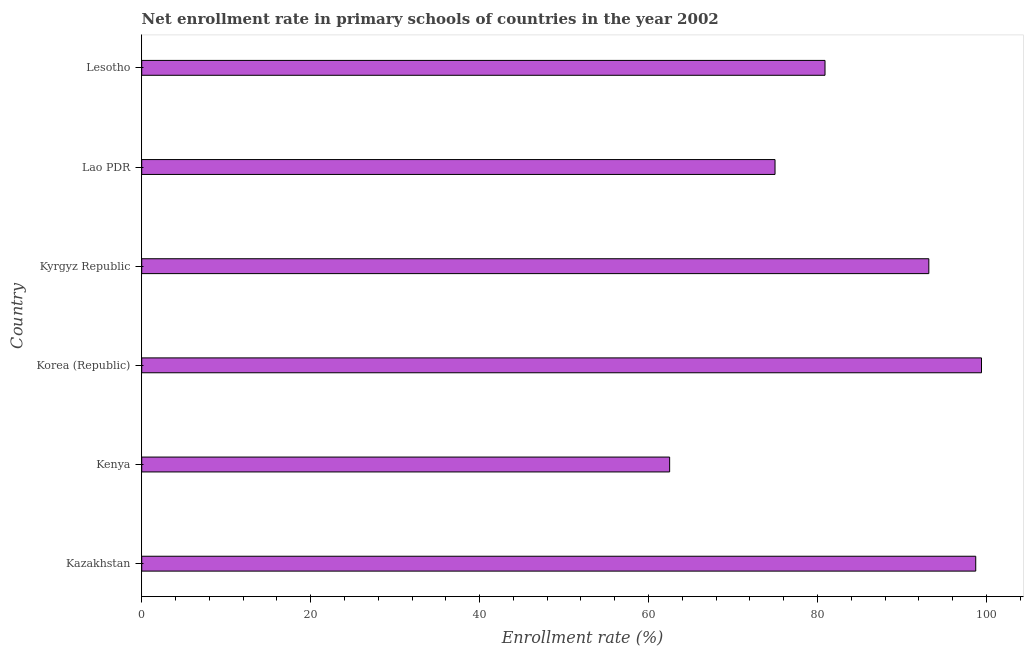Does the graph contain grids?
Your response must be concise. No. What is the title of the graph?
Make the answer very short. Net enrollment rate in primary schools of countries in the year 2002. What is the label or title of the X-axis?
Provide a succinct answer. Enrollment rate (%). What is the net enrollment rate in primary schools in Korea (Republic)?
Provide a succinct answer. 99.42. Across all countries, what is the maximum net enrollment rate in primary schools?
Offer a very short reply. 99.42. Across all countries, what is the minimum net enrollment rate in primary schools?
Keep it short and to the point. 62.5. In which country was the net enrollment rate in primary schools minimum?
Offer a very short reply. Kenya. What is the sum of the net enrollment rate in primary schools?
Provide a short and direct response. 509.72. What is the difference between the net enrollment rate in primary schools in Kyrgyz Republic and Lesotho?
Offer a terse response. 12.29. What is the average net enrollment rate in primary schools per country?
Provide a short and direct response. 84.95. What is the median net enrollment rate in primary schools?
Ensure brevity in your answer.  87.04. What is the ratio of the net enrollment rate in primary schools in Kazakhstan to that in Kenya?
Offer a terse response. 1.58. Is the net enrollment rate in primary schools in Kyrgyz Republic less than that in Lesotho?
Keep it short and to the point. No. Is the difference between the net enrollment rate in primary schools in Korea (Republic) and Lao PDR greater than the difference between any two countries?
Your answer should be very brief. No. What is the difference between the highest and the second highest net enrollment rate in primary schools?
Offer a terse response. 0.68. What is the difference between the highest and the lowest net enrollment rate in primary schools?
Give a very brief answer. 36.92. How many countries are there in the graph?
Give a very brief answer. 6. Are the values on the major ticks of X-axis written in scientific E-notation?
Keep it short and to the point. No. What is the Enrollment rate (%) in Kazakhstan?
Make the answer very short. 98.74. What is the Enrollment rate (%) in Kenya?
Offer a terse response. 62.5. What is the Enrollment rate (%) of Korea (Republic)?
Provide a succinct answer. 99.42. What is the Enrollment rate (%) in Kyrgyz Republic?
Your answer should be very brief. 93.19. What is the Enrollment rate (%) of Lao PDR?
Your response must be concise. 74.98. What is the Enrollment rate (%) in Lesotho?
Keep it short and to the point. 80.9. What is the difference between the Enrollment rate (%) in Kazakhstan and Kenya?
Make the answer very short. 36.24. What is the difference between the Enrollment rate (%) in Kazakhstan and Korea (Republic)?
Your answer should be very brief. -0.68. What is the difference between the Enrollment rate (%) in Kazakhstan and Kyrgyz Republic?
Offer a terse response. 5.55. What is the difference between the Enrollment rate (%) in Kazakhstan and Lao PDR?
Provide a succinct answer. 23.76. What is the difference between the Enrollment rate (%) in Kazakhstan and Lesotho?
Your answer should be compact. 17.84. What is the difference between the Enrollment rate (%) in Kenya and Korea (Republic)?
Give a very brief answer. -36.92. What is the difference between the Enrollment rate (%) in Kenya and Kyrgyz Republic?
Provide a succinct answer. -30.69. What is the difference between the Enrollment rate (%) in Kenya and Lao PDR?
Keep it short and to the point. -12.48. What is the difference between the Enrollment rate (%) in Kenya and Lesotho?
Ensure brevity in your answer.  -18.39. What is the difference between the Enrollment rate (%) in Korea (Republic) and Kyrgyz Republic?
Provide a succinct answer. 6.24. What is the difference between the Enrollment rate (%) in Korea (Republic) and Lao PDR?
Offer a terse response. 24.45. What is the difference between the Enrollment rate (%) in Korea (Republic) and Lesotho?
Offer a terse response. 18.53. What is the difference between the Enrollment rate (%) in Kyrgyz Republic and Lao PDR?
Provide a succinct answer. 18.21. What is the difference between the Enrollment rate (%) in Kyrgyz Republic and Lesotho?
Keep it short and to the point. 12.29. What is the difference between the Enrollment rate (%) in Lao PDR and Lesotho?
Ensure brevity in your answer.  -5.92. What is the ratio of the Enrollment rate (%) in Kazakhstan to that in Kenya?
Make the answer very short. 1.58. What is the ratio of the Enrollment rate (%) in Kazakhstan to that in Kyrgyz Republic?
Make the answer very short. 1.06. What is the ratio of the Enrollment rate (%) in Kazakhstan to that in Lao PDR?
Offer a terse response. 1.32. What is the ratio of the Enrollment rate (%) in Kazakhstan to that in Lesotho?
Give a very brief answer. 1.22. What is the ratio of the Enrollment rate (%) in Kenya to that in Korea (Republic)?
Offer a terse response. 0.63. What is the ratio of the Enrollment rate (%) in Kenya to that in Kyrgyz Republic?
Your response must be concise. 0.67. What is the ratio of the Enrollment rate (%) in Kenya to that in Lao PDR?
Provide a succinct answer. 0.83. What is the ratio of the Enrollment rate (%) in Kenya to that in Lesotho?
Keep it short and to the point. 0.77. What is the ratio of the Enrollment rate (%) in Korea (Republic) to that in Kyrgyz Republic?
Offer a terse response. 1.07. What is the ratio of the Enrollment rate (%) in Korea (Republic) to that in Lao PDR?
Make the answer very short. 1.33. What is the ratio of the Enrollment rate (%) in Korea (Republic) to that in Lesotho?
Give a very brief answer. 1.23. What is the ratio of the Enrollment rate (%) in Kyrgyz Republic to that in Lao PDR?
Provide a succinct answer. 1.24. What is the ratio of the Enrollment rate (%) in Kyrgyz Republic to that in Lesotho?
Offer a terse response. 1.15. What is the ratio of the Enrollment rate (%) in Lao PDR to that in Lesotho?
Ensure brevity in your answer.  0.93. 